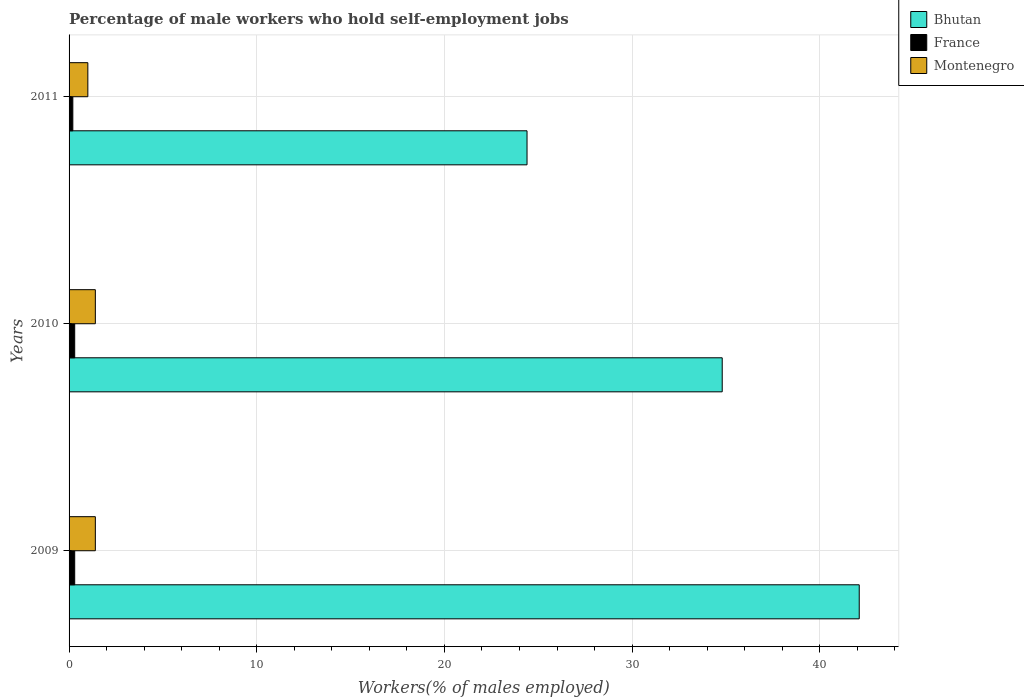Are the number of bars on each tick of the Y-axis equal?
Give a very brief answer. Yes. How many bars are there on the 3rd tick from the top?
Ensure brevity in your answer.  3. What is the label of the 3rd group of bars from the top?
Your response must be concise. 2009. In how many cases, is the number of bars for a given year not equal to the number of legend labels?
Provide a short and direct response. 0. What is the percentage of self-employed male workers in France in 2011?
Provide a succinct answer. 0.2. Across all years, what is the maximum percentage of self-employed male workers in France?
Keep it short and to the point. 0.3. Across all years, what is the minimum percentage of self-employed male workers in Montenegro?
Ensure brevity in your answer.  1. In which year was the percentage of self-employed male workers in Montenegro minimum?
Provide a short and direct response. 2011. What is the total percentage of self-employed male workers in France in the graph?
Your response must be concise. 0.8. What is the difference between the percentage of self-employed male workers in Bhutan in 2009 and that in 2011?
Offer a terse response. 17.7. What is the difference between the percentage of self-employed male workers in France in 2009 and the percentage of self-employed male workers in Montenegro in 2011?
Give a very brief answer. -0.7. What is the average percentage of self-employed male workers in Bhutan per year?
Your answer should be very brief. 33.77. In the year 2009, what is the difference between the percentage of self-employed male workers in Bhutan and percentage of self-employed male workers in France?
Offer a very short reply. 41.8. In how many years, is the percentage of self-employed male workers in Bhutan greater than 22 %?
Give a very brief answer. 3. What is the ratio of the percentage of self-employed male workers in Bhutan in 2009 to that in 2010?
Your answer should be compact. 1.21. What is the difference between the highest and the second highest percentage of self-employed male workers in France?
Your answer should be very brief. 0. What is the difference between the highest and the lowest percentage of self-employed male workers in Montenegro?
Your answer should be very brief. 0.4. In how many years, is the percentage of self-employed male workers in Bhutan greater than the average percentage of self-employed male workers in Bhutan taken over all years?
Offer a very short reply. 2. What does the 1st bar from the top in 2009 represents?
Your response must be concise. Montenegro. Is it the case that in every year, the sum of the percentage of self-employed male workers in France and percentage of self-employed male workers in Bhutan is greater than the percentage of self-employed male workers in Montenegro?
Offer a terse response. Yes. How many bars are there?
Your answer should be very brief. 9. How many years are there in the graph?
Make the answer very short. 3. Does the graph contain any zero values?
Ensure brevity in your answer.  No. Where does the legend appear in the graph?
Your answer should be very brief. Top right. How are the legend labels stacked?
Your answer should be compact. Vertical. What is the title of the graph?
Give a very brief answer. Percentage of male workers who hold self-employment jobs. What is the label or title of the X-axis?
Make the answer very short. Workers(% of males employed). What is the label or title of the Y-axis?
Offer a very short reply. Years. What is the Workers(% of males employed) of Bhutan in 2009?
Give a very brief answer. 42.1. What is the Workers(% of males employed) in France in 2009?
Your answer should be compact. 0.3. What is the Workers(% of males employed) of Montenegro in 2009?
Ensure brevity in your answer.  1.4. What is the Workers(% of males employed) in Bhutan in 2010?
Make the answer very short. 34.8. What is the Workers(% of males employed) of France in 2010?
Keep it short and to the point. 0.3. What is the Workers(% of males employed) of Montenegro in 2010?
Your answer should be very brief. 1.4. What is the Workers(% of males employed) of Bhutan in 2011?
Your response must be concise. 24.4. What is the Workers(% of males employed) of France in 2011?
Offer a terse response. 0.2. What is the Workers(% of males employed) in Montenegro in 2011?
Give a very brief answer. 1. Across all years, what is the maximum Workers(% of males employed) in Bhutan?
Provide a short and direct response. 42.1. Across all years, what is the maximum Workers(% of males employed) of France?
Your answer should be very brief. 0.3. Across all years, what is the maximum Workers(% of males employed) in Montenegro?
Provide a succinct answer. 1.4. Across all years, what is the minimum Workers(% of males employed) of Bhutan?
Ensure brevity in your answer.  24.4. Across all years, what is the minimum Workers(% of males employed) in France?
Your response must be concise. 0.2. What is the total Workers(% of males employed) in Bhutan in the graph?
Give a very brief answer. 101.3. What is the difference between the Workers(% of males employed) in France in 2009 and that in 2010?
Provide a succinct answer. 0. What is the difference between the Workers(% of males employed) of Montenegro in 2009 and that in 2010?
Ensure brevity in your answer.  0. What is the difference between the Workers(% of males employed) in Bhutan in 2010 and that in 2011?
Provide a short and direct response. 10.4. What is the difference between the Workers(% of males employed) in Montenegro in 2010 and that in 2011?
Keep it short and to the point. 0.4. What is the difference between the Workers(% of males employed) of Bhutan in 2009 and the Workers(% of males employed) of France in 2010?
Your answer should be compact. 41.8. What is the difference between the Workers(% of males employed) of Bhutan in 2009 and the Workers(% of males employed) of Montenegro in 2010?
Provide a succinct answer. 40.7. What is the difference between the Workers(% of males employed) in Bhutan in 2009 and the Workers(% of males employed) in France in 2011?
Your response must be concise. 41.9. What is the difference between the Workers(% of males employed) of Bhutan in 2009 and the Workers(% of males employed) of Montenegro in 2011?
Offer a very short reply. 41.1. What is the difference between the Workers(% of males employed) of Bhutan in 2010 and the Workers(% of males employed) of France in 2011?
Your answer should be compact. 34.6. What is the difference between the Workers(% of males employed) of Bhutan in 2010 and the Workers(% of males employed) of Montenegro in 2011?
Your answer should be very brief. 33.8. What is the average Workers(% of males employed) in Bhutan per year?
Give a very brief answer. 33.77. What is the average Workers(% of males employed) in France per year?
Provide a short and direct response. 0.27. What is the average Workers(% of males employed) of Montenegro per year?
Your answer should be very brief. 1.27. In the year 2009, what is the difference between the Workers(% of males employed) of Bhutan and Workers(% of males employed) of France?
Provide a short and direct response. 41.8. In the year 2009, what is the difference between the Workers(% of males employed) of Bhutan and Workers(% of males employed) of Montenegro?
Your answer should be compact. 40.7. In the year 2009, what is the difference between the Workers(% of males employed) in France and Workers(% of males employed) in Montenegro?
Your response must be concise. -1.1. In the year 2010, what is the difference between the Workers(% of males employed) in Bhutan and Workers(% of males employed) in France?
Give a very brief answer. 34.5. In the year 2010, what is the difference between the Workers(% of males employed) in Bhutan and Workers(% of males employed) in Montenegro?
Your answer should be very brief. 33.4. In the year 2010, what is the difference between the Workers(% of males employed) of France and Workers(% of males employed) of Montenegro?
Ensure brevity in your answer.  -1.1. In the year 2011, what is the difference between the Workers(% of males employed) in Bhutan and Workers(% of males employed) in France?
Provide a short and direct response. 24.2. In the year 2011, what is the difference between the Workers(% of males employed) of Bhutan and Workers(% of males employed) of Montenegro?
Provide a succinct answer. 23.4. What is the ratio of the Workers(% of males employed) in Bhutan in 2009 to that in 2010?
Your answer should be very brief. 1.21. What is the ratio of the Workers(% of males employed) of France in 2009 to that in 2010?
Provide a short and direct response. 1. What is the ratio of the Workers(% of males employed) of Bhutan in 2009 to that in 2011?
Your response must be concise. 1.73. What is the ratio of the Workers(% of males employed) in France in 2009 to that in 2011?
Offer a terse response. 1.5. What is the ratio of the Workers(% of males employed) in Montenegro in 2009 to that in 2011?
Keep it short and to the point. 1.4. What is the ratio of the Workers(% of males employed) in Bhutan in 2010 to that in 2011?
Make the answer very short. 1.43. What is the ratio of the Workers(% of males employed) in France in 2010 to that in 2011?
Give a very brief answer. 1.5. What is the difference between the highest and the second highest Workers(% of males employed) of Bhutan?
Offer a terse response. 7.3. What is the difference between the highest and the lowest Workers(% of males employed) in France?
Keep it short and to the point. 0.1. What is the difference between the highest and the lowest Workers(% of males employed) in Montenegro?
Ensure brevity in your answer.  0.4. 